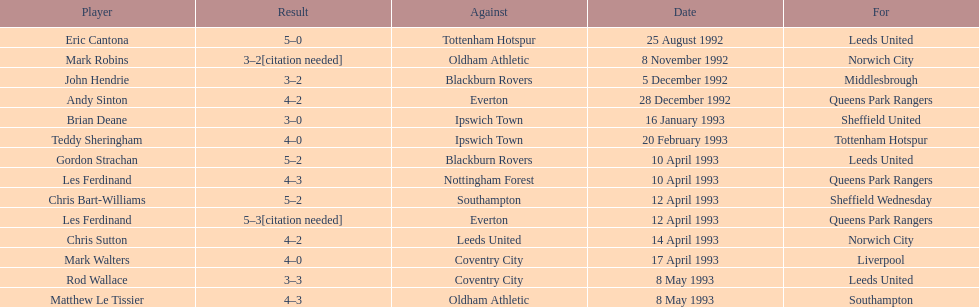In the 1992-1993 premier league, what was the total number of hat tricks scored by all players? 14. 